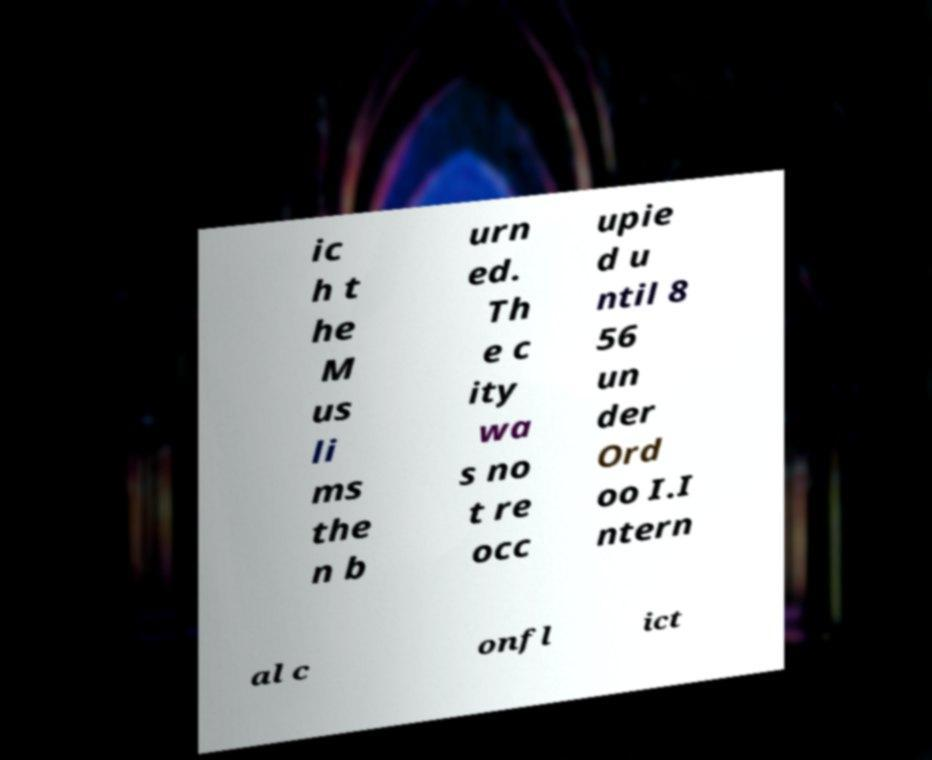I need the written content from this picture converted into text. Can you do that? ic h t he M us li ms the n b urn ed. Th e c ity wa s no t re occ upie d u ntil 8 56 un der Ord oo I.I ntern al c onfl ict 